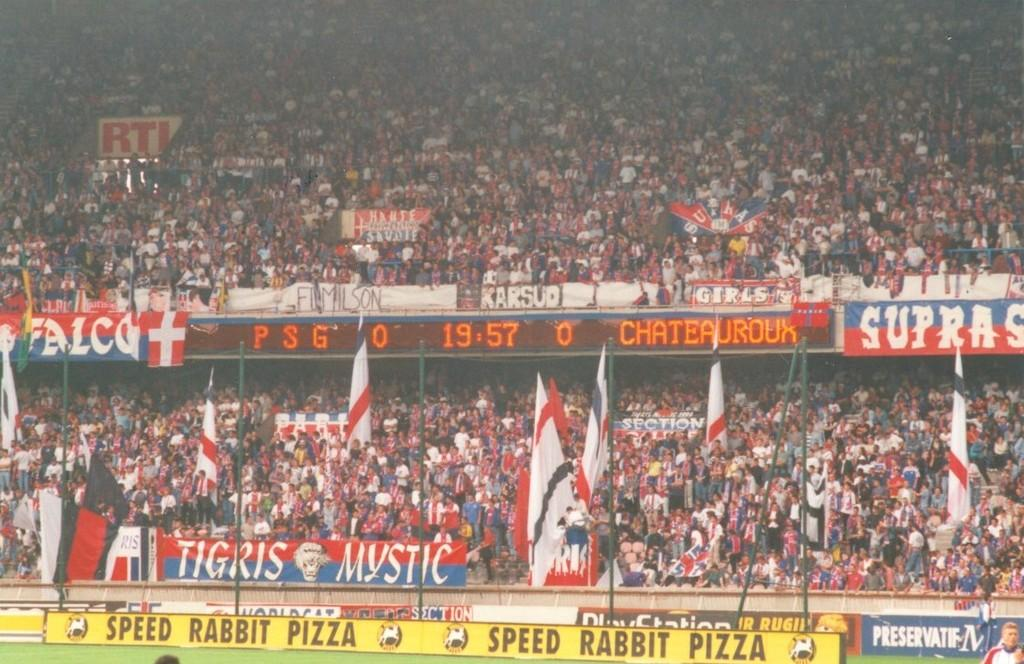What is happening in the image? There are people standing in the stadium, which suggests an event or gathering is taking place. What can be seen on the boards with text in the image? The specific text on the boards is not visible, but we know that there are boards with text present. What is the purpose of the screen in the image? The screen in the image is likely used for displaying information, advertisements, or live footage of the event. What type of decorations are present in the image? Banners and flags are visible in the image, which are often used for decoration or to show support for a team or cause. What is visible on the ground in the image? The ground is visible in the image, but the specific surface or material cannot be determined from the provided facts. What is the rate of the wing's movement in the image? There is no wing present in the image, so it is not possible to determine the rate of its movement. 